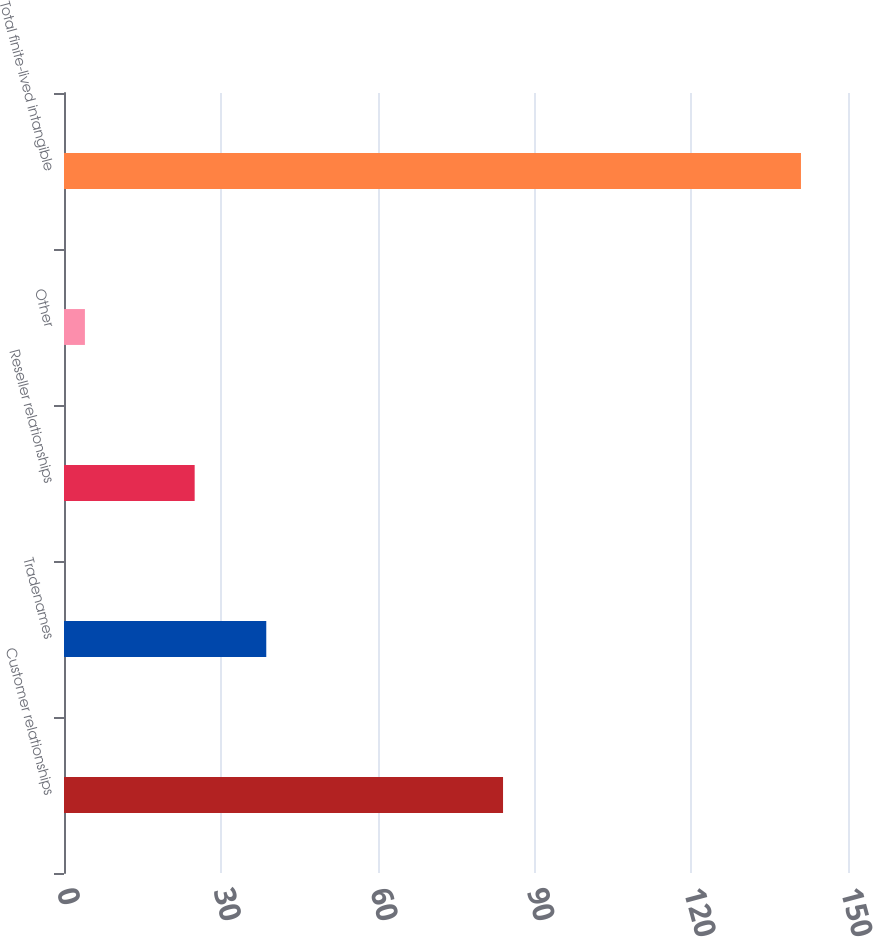Convert chart. <chart><loc_0><loc_0><loc_500><loc_500><bar_chart><fcel>Customer relationships<fcel>Tradenames<fcel>Reseller relationships<fcel>Other<fcel>Total finite-lived intangible<nl><fcel>84<fcel>38.7<fcel>25<fcel>4<fcel>141<nl></chart> 